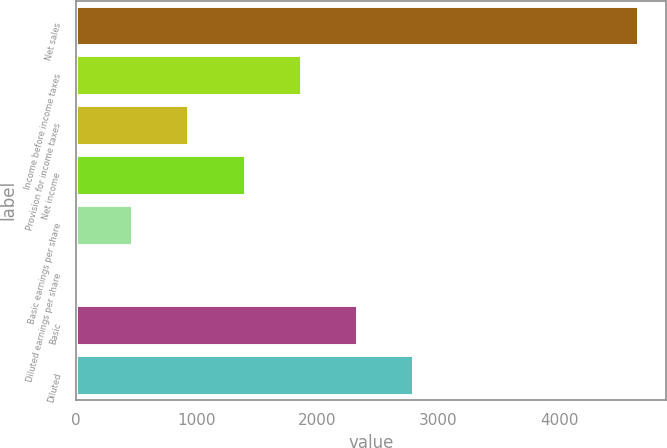<chart> <loc_0><loc_0><loc_500><loc_500><bar_chart><fcel>Net sales<fcel>Income before income taxes<fcel>Provision for income taxes<fcel>Net income<fcel>Basic earnings per share<fcel>Diluted earnings per share<fcel>Basic<fcel>Diluted<nl><fcel>4651<fcel>1860.6<fcel>930.46<fcel>1395.53<fcel>465.39<fcel>0.32<fcel>2325.67<fcel>2790.74<nl></chart> 